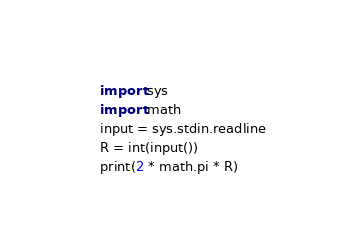<code> <loc_0><loc_0><loc_500><loc_500><_Python_>import sys
import math
input = sys.stdin.readline
R = int(input())
print(2 * math.pi * R)
</code> 